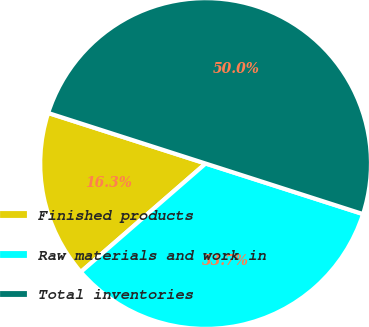<chart> <loc_0><loc_0><loc_500><loc_500><pie_chart><fcel>Finished products<fcel>Raw materials and work in<fcel>Total inventories<nl><fcel>16.33%<fcel>33.67%<fcel>50.0%<nl></chart> 